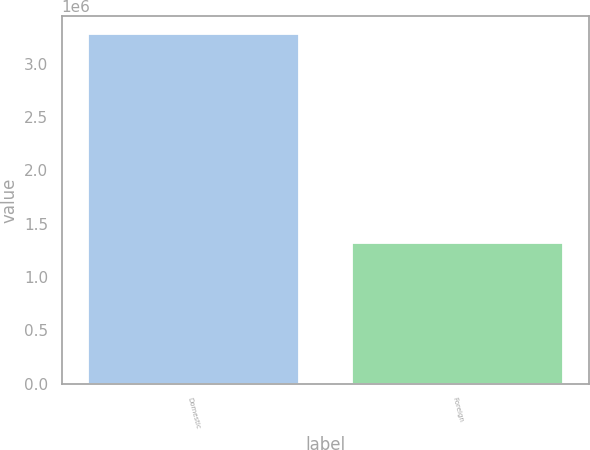Convert chart to OTSL. <chart><loc_0><loc_0><loc_500><loc_500><bar_chart><fcel>Domestic<fcel>Foreign<nl><fcel>3.27859e+06<fcel>1.32196e+06<nl></chart> 